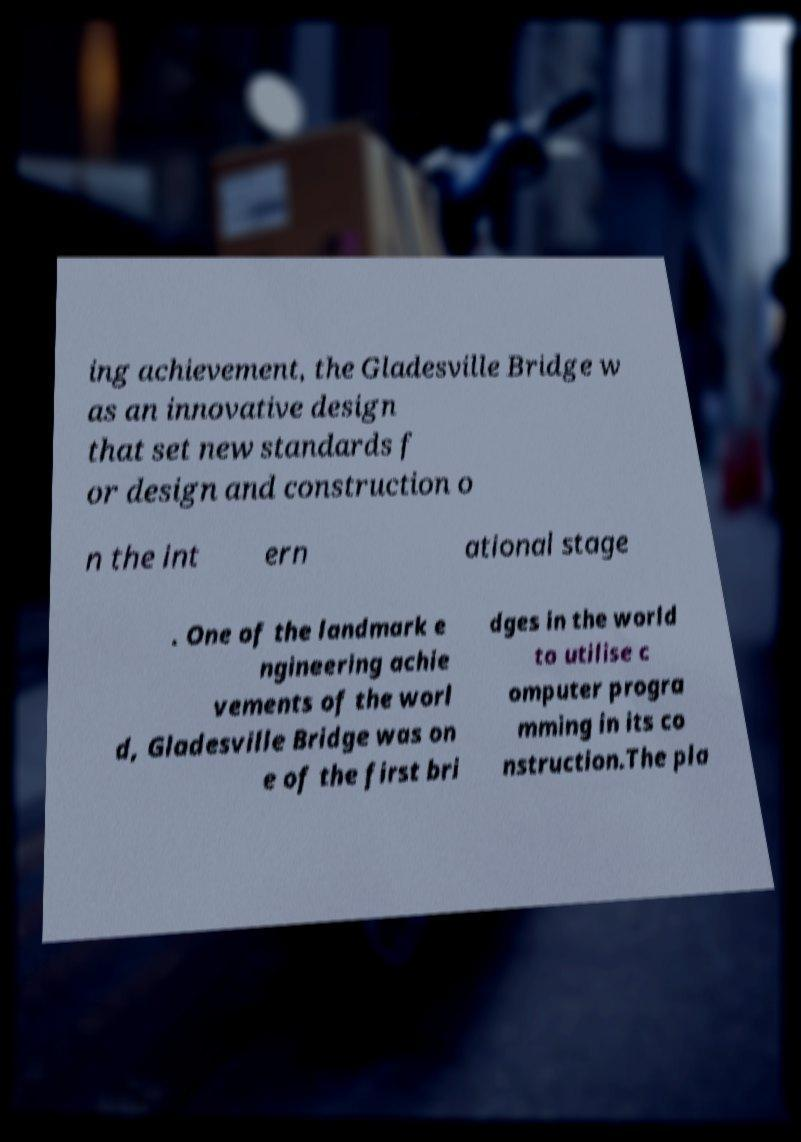Could you assist in decoding the text presented in this image and type it out clearly? ing achievement, the Gladesville Bridge w as an innovative design that set new standards f or design and construction o n the int ern ational stage . One of the landmark e ngineering achie vements of the worl d, Gladesville Bridge was on e of the first bri dges in the world to utilise c omputer progra mming in its co nstruction.The pla 